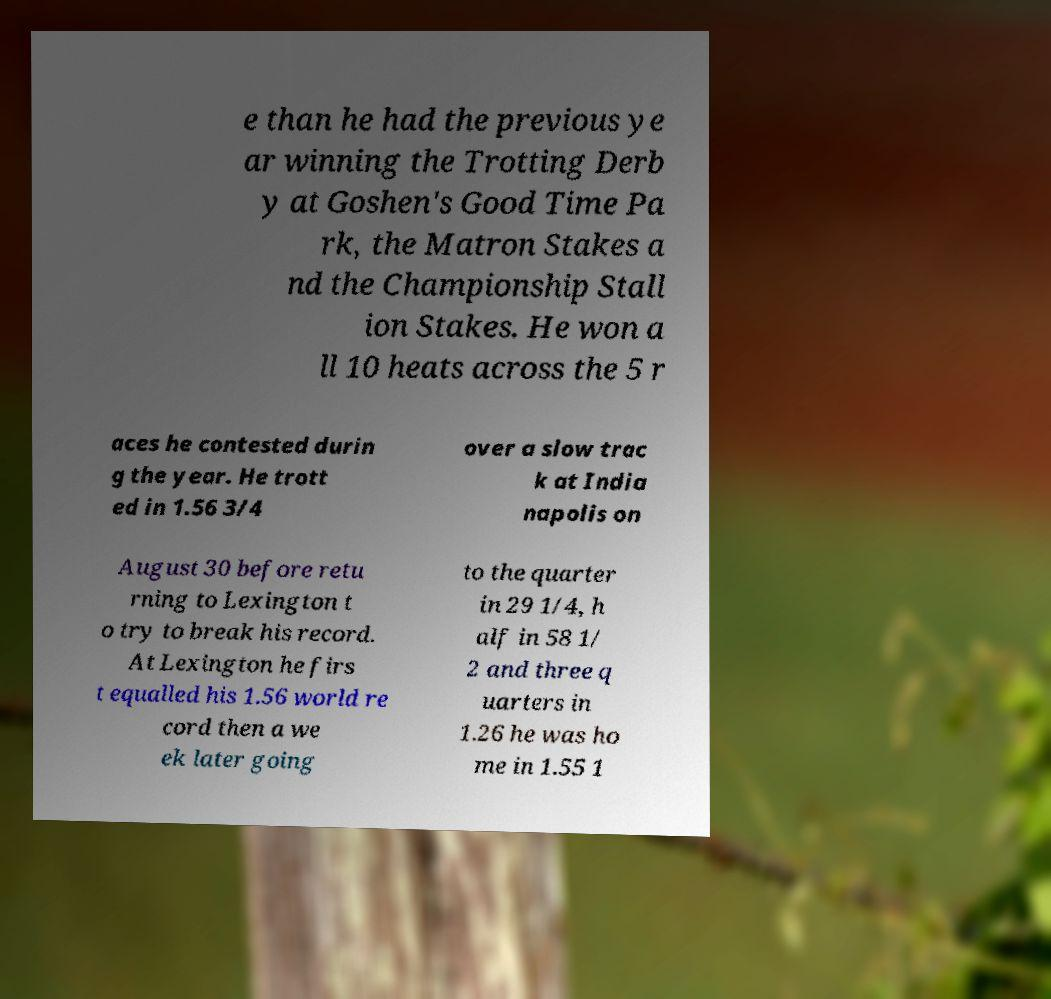Could you assist in decoding the text presented in this image and type it out clearly? e than he had the previous ye ar winning the Trotting Derb y at Goshen's Good Time Pa rk, the Matron Stakes a nd the Championship Stall ion Stakes. He won a ll 10 heats across the 5 r aces he contested durin g the year. He trott ed in 1.56 3/4 over a slow trac k at India napolis on August 30 before retu rning to Lexington t o try to break his record. At Lexington he firs t equalled his 1.56 world re cord then a we ek later going to the quarter in 29 1/4, h alf in 58 1/ 2 and three q uarters in 1.26 he was ho me in 1.55 1 